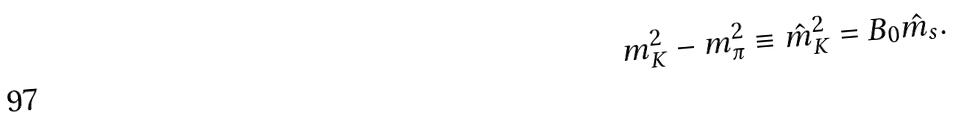<formula> <loc_0><loc_0><loc_500><loc_500>m _ { K } ^ { 2 } - m _ { \pi } ^ { 2 } \equiv \hat { m } _ { K } ^ { 2 } = B _ { 0 } \hat { m } _ { s } .</formula> 